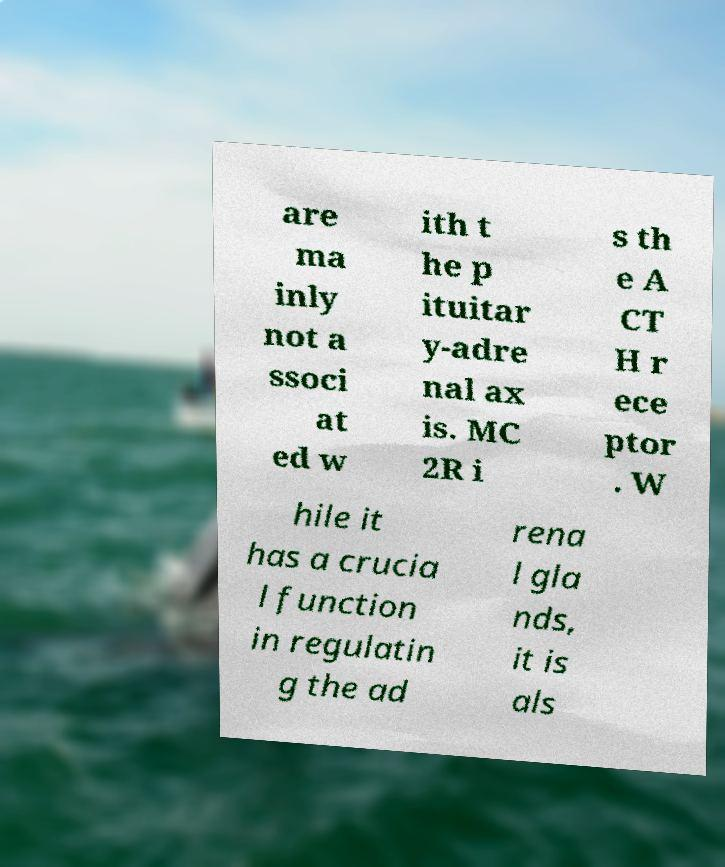I need the written content from this picture converted into text. Can you do that? are ma inly not a ssoci at ed w ith t he p ituitar y-adre nal ax is. MC 2R i s th e A CT H r ece ptor . W hile it has a crucia l function in regulatin g the ad rena l gla nds, it is als 